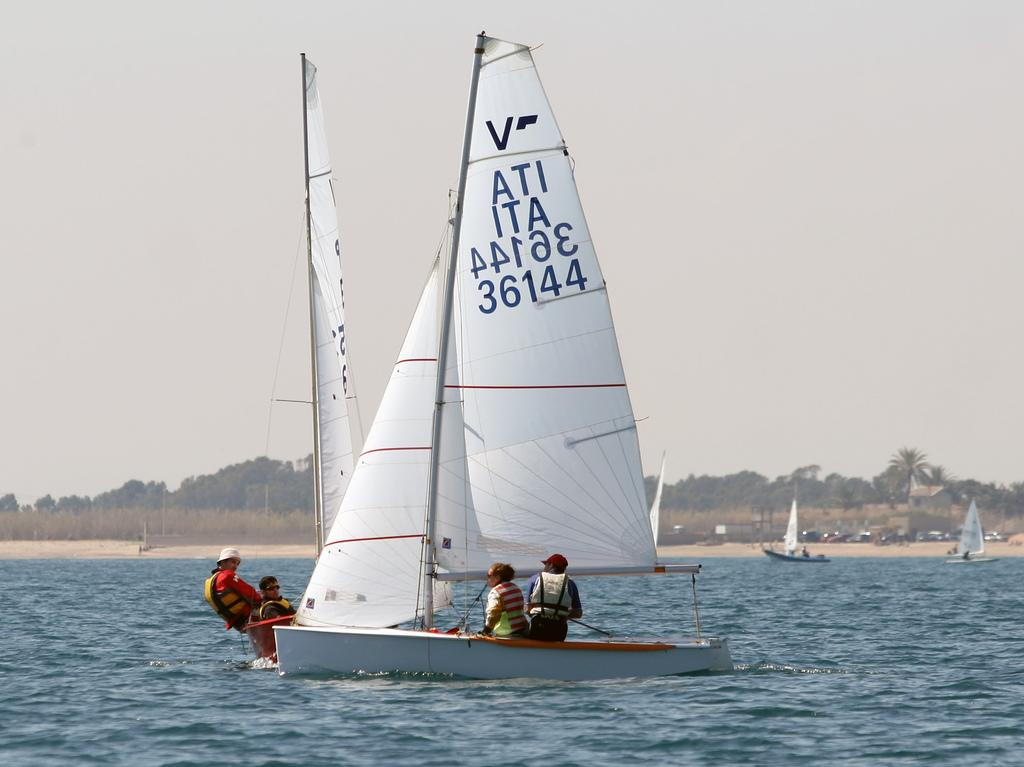What is happening in the image? There are boats sailing in the image. Where are the boats located? The boats are on a sea. What can be seen in the background of the image? There is a seashore visible in the background, along with trees and a cloudy sky. What type of needle is being used to sew the agreement on the seashore in the image? There is no needle or agreement present in the image; it features boats sailing on a sea with a background of a seashore, trees, and a cloudy sky. 